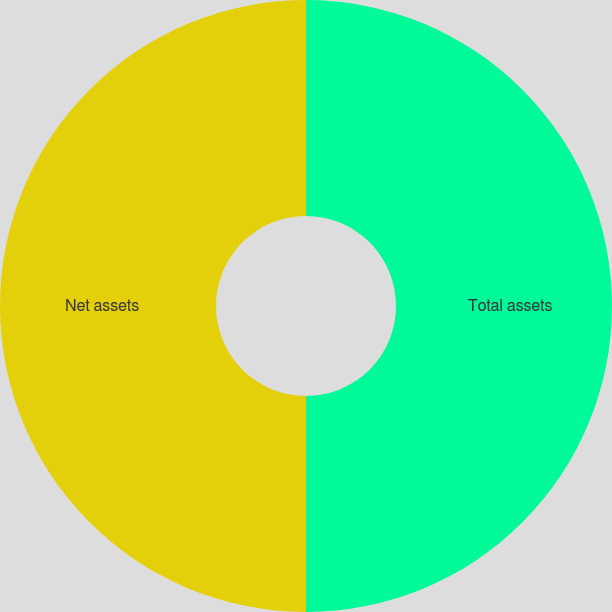Convert chart to OTSL. <chart><loc_0><loc_0><loc_500><loc_500><pie_chart><fcel>Total assets<fcel>Net assets<nl><fcel>50.0%<fcel>50.0%<nl></chart> 